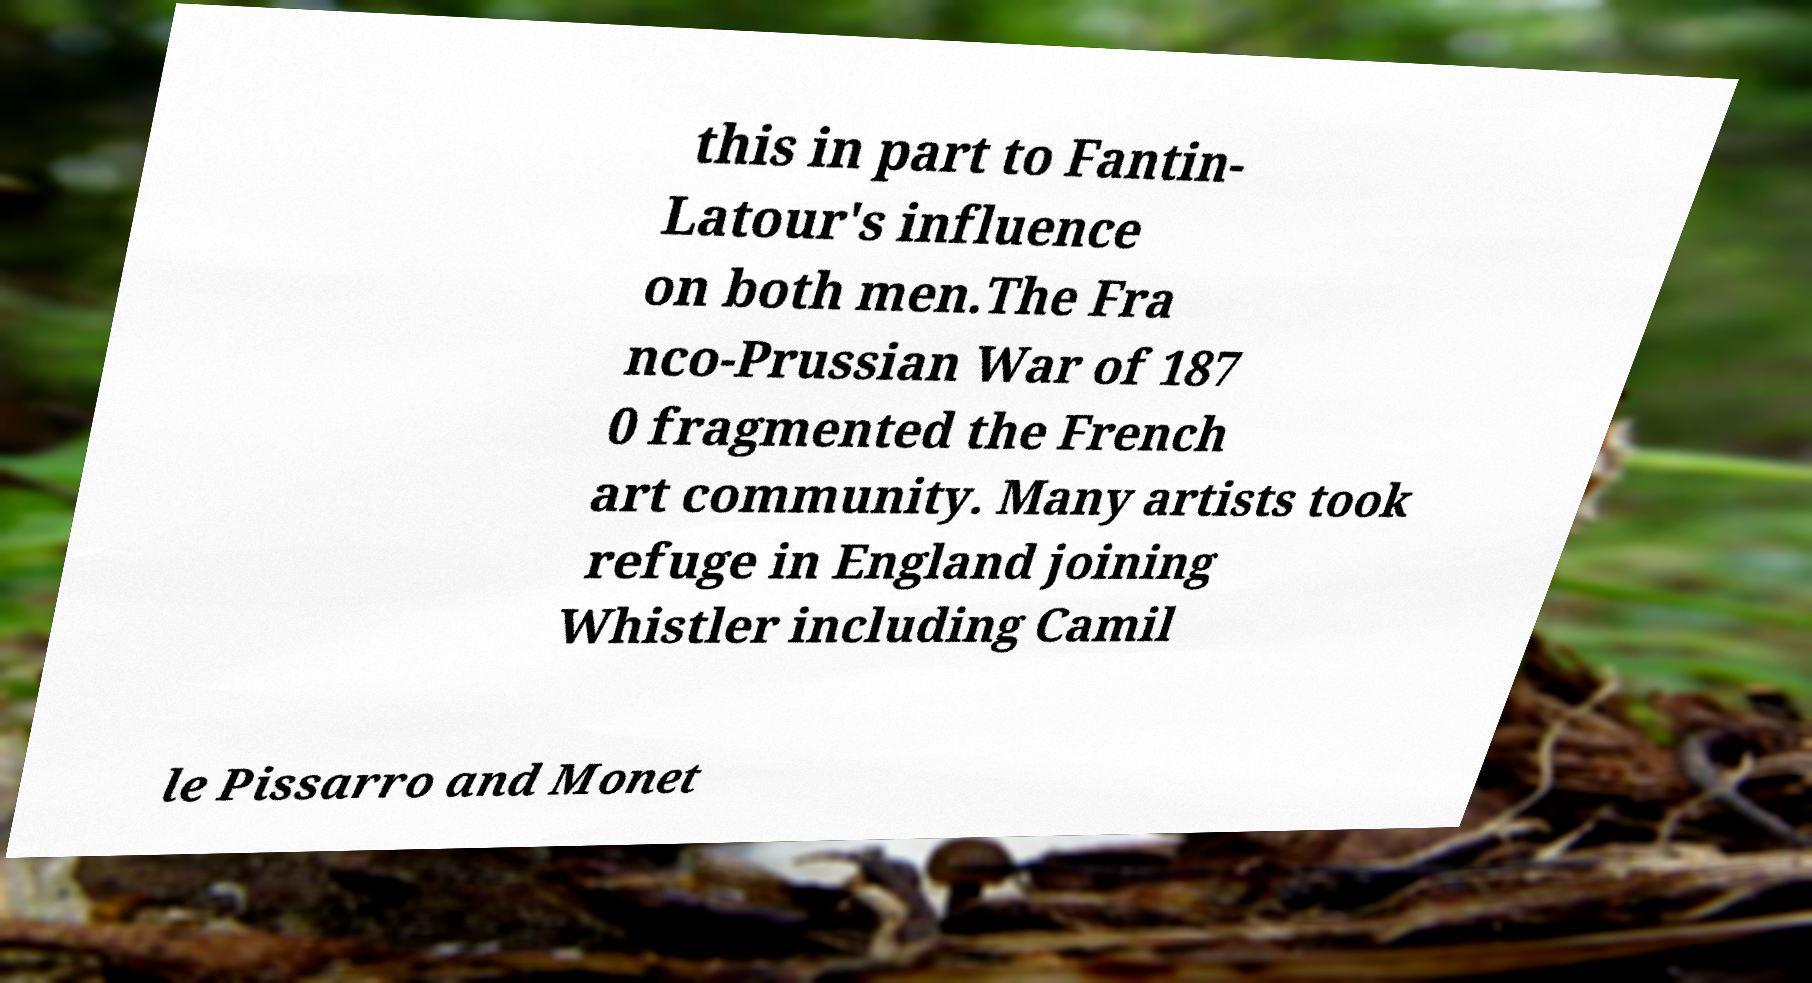What messages or text are displayed in this image? I need them in a readable, typed format. this in part to Fantin- Latour's influence on both men.The Fra nco-Prussian War of 187 0 fragmented the French art community. Many artists took refuge in England joining Whistler including Camil le Pissarro and Monet 